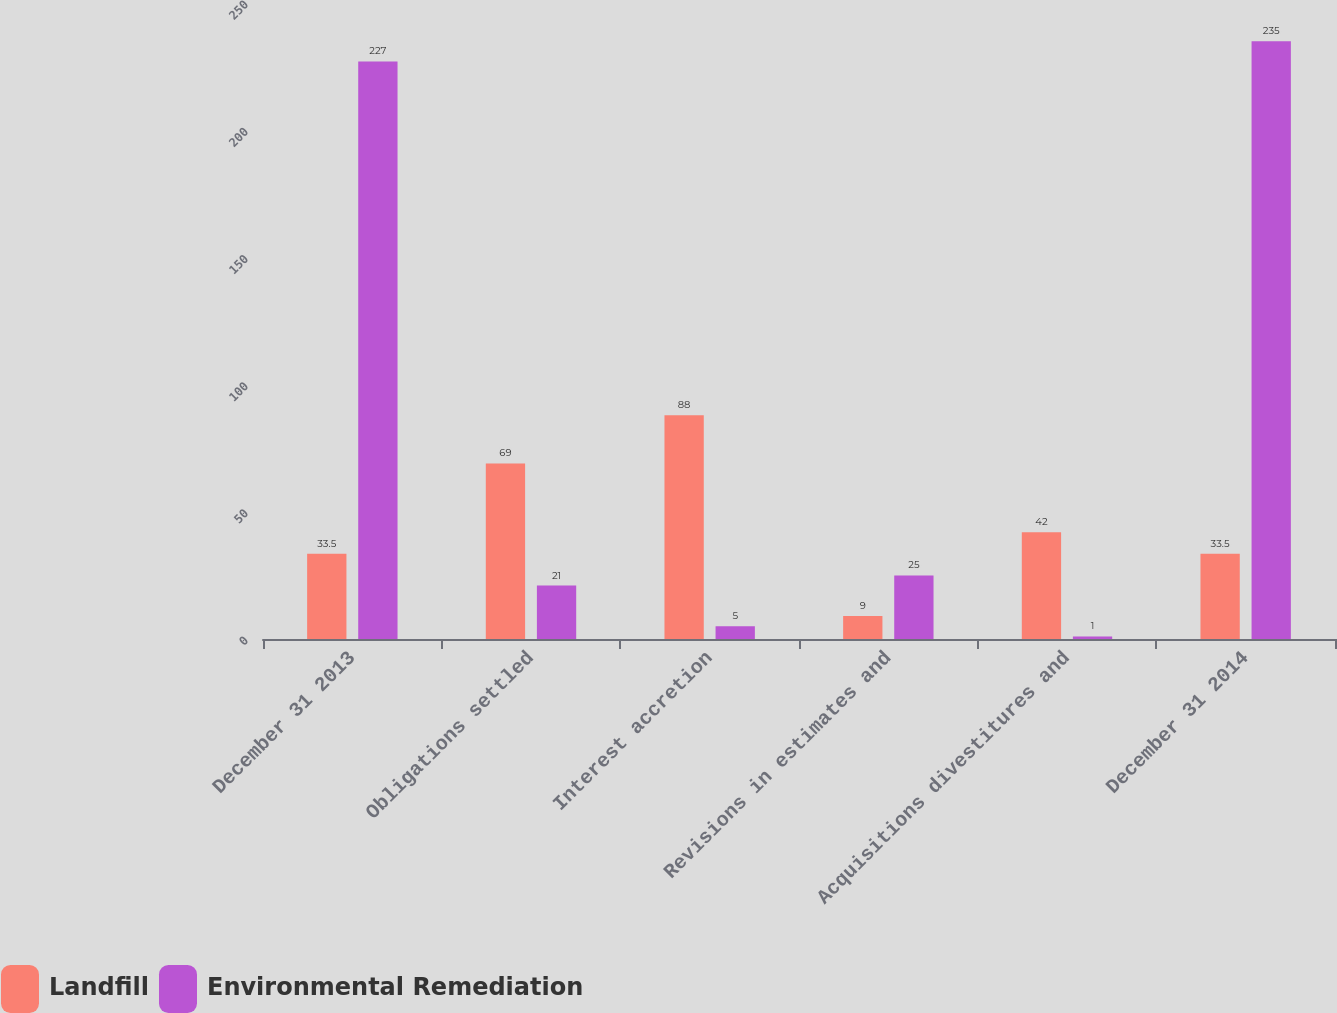Convert chart. <chart><loc_0><loc_0><loc_500><loc_500><stacked_bar_chart><ecel><fcel>December 31 2013<fcel>Obligations settled<fcel>Interest accretion<fcel>Revisions in estimates and<fcel>Acquisitions divestitures and<fcel>December 31 2014<nl><fcel>Landfill<fcel>33.5<fcel>69<fcel>88<fcel>9<fcel>42<fcel>33.5<nl><fcel>Environmental Remediation<fcel>227<fcel>21<fcel>5<fcel>25<fcel>1<fcel>235<nl></chart> 